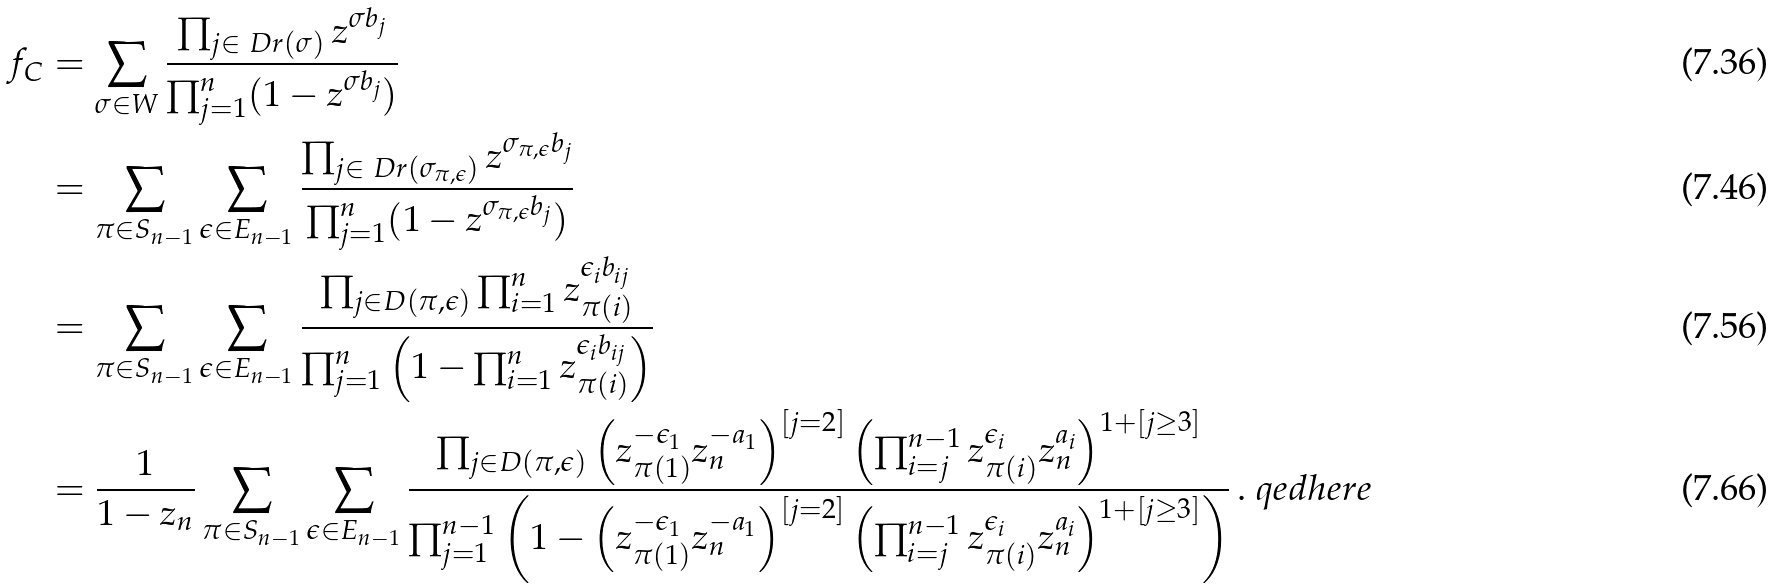<formula> <loc_0><loc_0><loc_500><loc_500>f _ { C } & = \sum _ { \sigma \in W } \frac { \prod _ { j \in \ D r ( \sigma ) } z ^ { \sigma b _ { j } } } { \prod _ { j = 1 } ^ { n } ( 1 - z ^ { \sigma b _ { j } } ) } \\ & = \sum _ { \pi \in S _ { n - 1 } } \sum _ { \epsilon \in E _ { n - 1 } } \frac { \prod _ { j \in \ D r ( \sigma _ { \pi , \epsilon } ) } z ^ { \sigma _ { \pi , \epsilon } b _ { j } } } { \prod _ { j = 1 } ^ { n } ( 1 - z ^ { \sigma _ { \pi , \epsilon } b _ { j } } ) } \\ & = \sum _ { \pi \in S _ { n - 1 } } \sum _ { \epsilon \in E _ { n - 1 } } \frac { \prod _ { j \in D ( \pi , \epsilon ) } \prod _ { i = 1 } ^ { n } z _ { \pi ( i ) } ^ { \epsilon _ { i } b _ { i j } } } { \prod _ { j = 1 } ^ { n } \left ( 1 - \prod _ { i = 1 } ^ { n } z _ { \pi ( i ) } ^ { \epsilon _ { i } b _ { i j } } \right ) } \\ & = \frac { 1 } { 1 - z _ { n } } \sum _ { \pi \in S _ { n - 1 } } \sum _ { \epsilon \in E _ { n - 1 } } \frac { \prod _ { j \in D ( \pi , \epsilon ) } \left ( z _ { \pi ( 1 ) } ^ { - \epsilon _ { 1 } } z _ { n } ^ { - a _ { 1 } } \right ) ^ { [ j = 2 ] } \left ( \prod _ { i = j } ^ { n - 1 } z _ { \pi ( i ) } ^ { \epsilon _ { i } } z _ { n } ^ { a _ { i } } \right ) ^ { 1 + [ j \geq 3 ] } } { \prod _ { j = 1 } ^ { n - 1 } \left ( 1 - \left ( z _ { \pi ( 1 ) } ^ { - \epsilon _ { 1 } } z _ { n } ^ { - a _ { 1 } } \right ) ^ { [ j = 2 ] } \left ( \prod _ { i = j } ^ { n - 1 } z _ { \pi ( i ) } ^ { \epsilon _ { i } } z _ { n } ^ { a _ { i } } \right ) ^ { 1 + [ j \geq 3 ] } \right ) } \, . \ q e d h e r e</formula> 